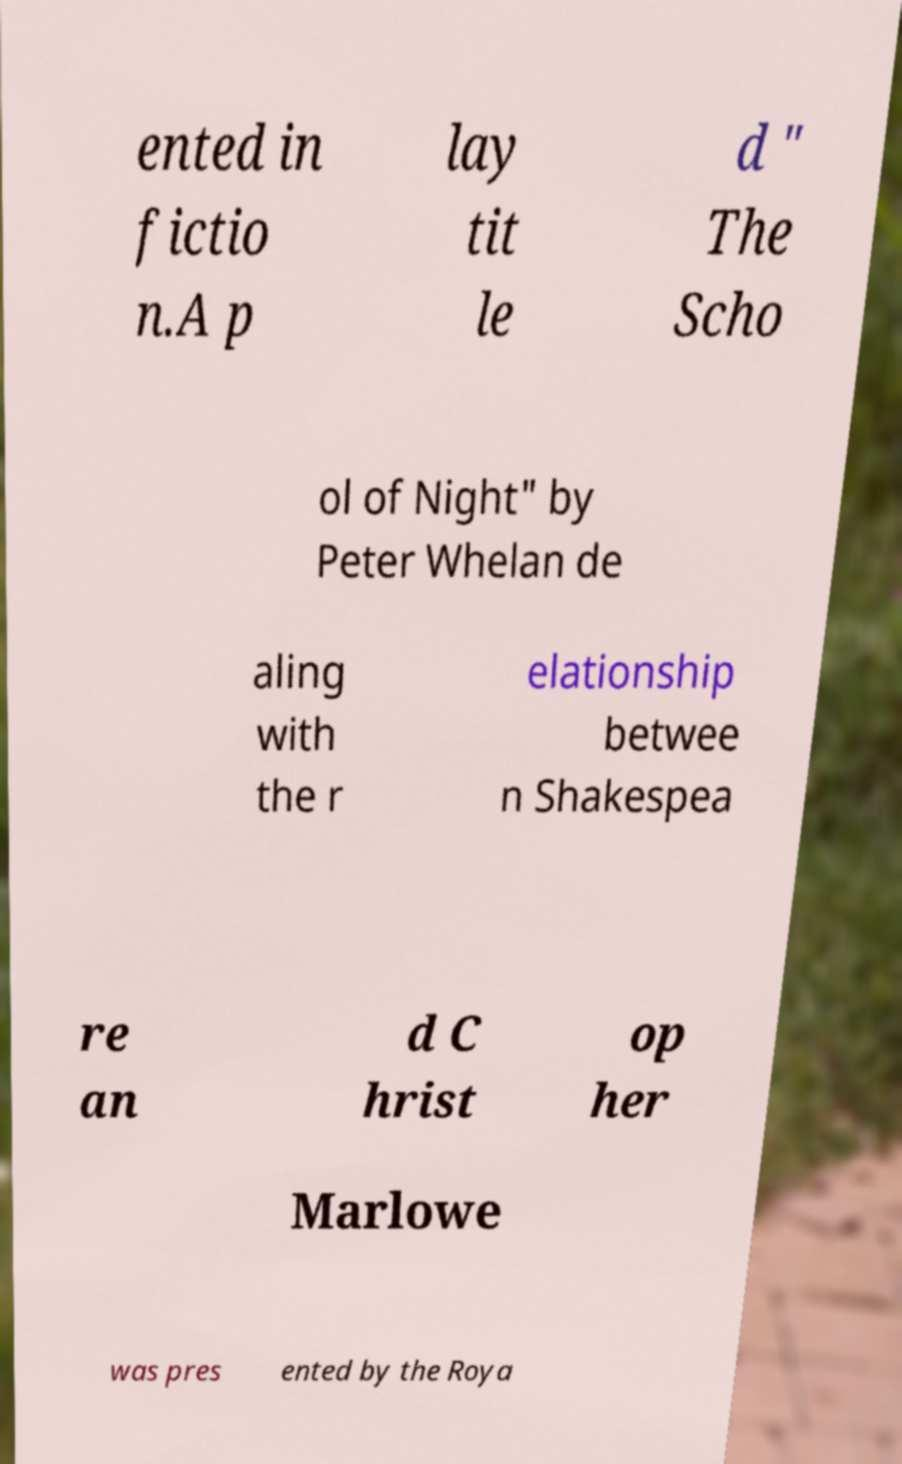What messages or text are displayed in this image? I need them in a readable, typed format. ented in fictio n.A p lay tit le d " The Scho ol of Night" by Peter Whelan de aling with the r elationship betwee n Shakespea re an d C hrist op her Marlowe was pres ented by the Roya 